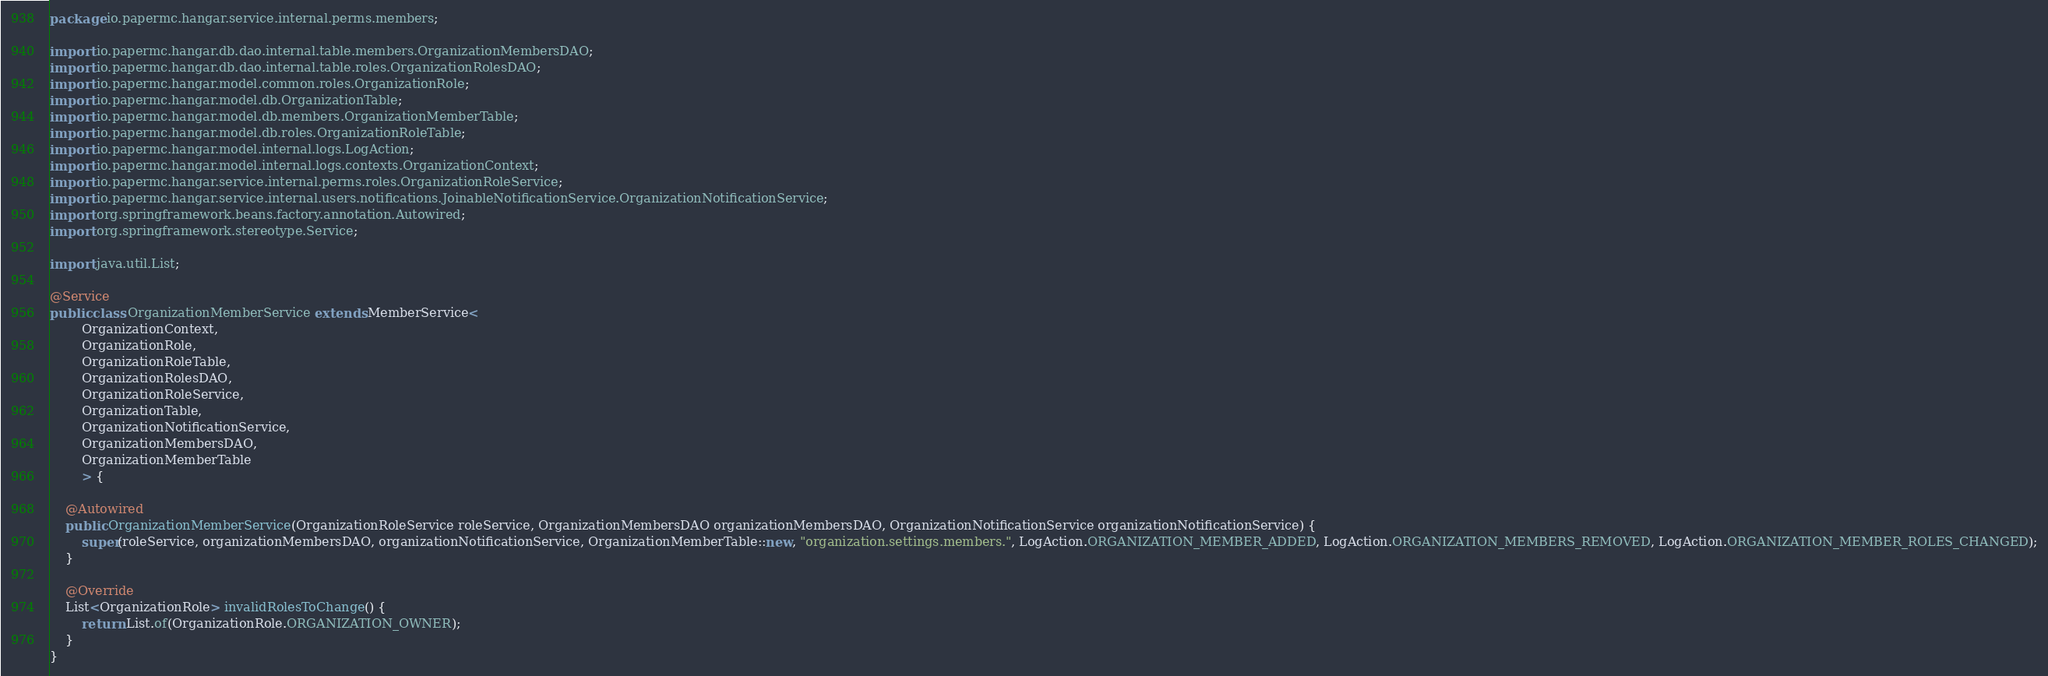Convert code to text. <code><loc_0><loc_0><loc_500><loc_500><_Java_>package io.papermc.hangar.service.internal.perms.members;

import io.papermc.hangar.db.dao.internal.table.members.OrganizationMembersDAO;
import io.papermc.hangar.db.dao.internal.table.roles.OrganizationRolesDAO;
import io.papermc.hangar.model.common.roles.OrganizationRole;
import io.papermc.hangar.model.db.OrganizationTable;
import io.papermc.hangar.model.db.members.OrganizationMemberTable;
import io.papermc.hangar.model.db.roles.OrganizationRoleTable;
import io.papermc.hangar.model.internal.logs.LogAction;
import io.papermc.hangar.model.internal.logs.contexts.OrganizationContext;
import io.papermc.hangar.service.internal.perms.roles.OrganizationRoleService;
import io.papermc.hangar.service.internal.users.notifications.JoinableNotificationService.OrganizationNotificationService;
import org.springframework.beans.factory.annotation.Autowired;
import org.springframework.stereotype.Service;

import java.util.List;

@Service
public class OrganizationMemberService extends MemberService<
        OrganizationContext,
        OrganizationRole,
        OrganizationRoleTable,
        OrganizationRolesDAO,
        OrganizationRoleService,
        OrganizationTable,
        OrganizationNotificationService,
        OrganizationMembersDAO,
        OrganizationMemberTable
        > {

    @Autowired
    public OrganizationMemberService(OrganizationRoleService roleService, OrganizationMembersDAO organizationMembersDAO, OrganizationNotificationService organizationNotificationService) {
        super(roleService, organizationMembersDAO, organizationNotificationService, OrganizationMemberTable::new, "organization.settings.members.", LogAction.ORGANIZATION_MEMBER_ADDED, LogAction.ORGANIZATION_MEMBERS_REMOVED, LogAction.ORGANIZATION_MEMBER_ROLES_CHANGED);
    }

    @Override
    List<OrganizationRole> invalidRolesToChange() {
        return List.of(OrganizationRole.ORGANIZATION_OWNER);
    }
}
</code> 